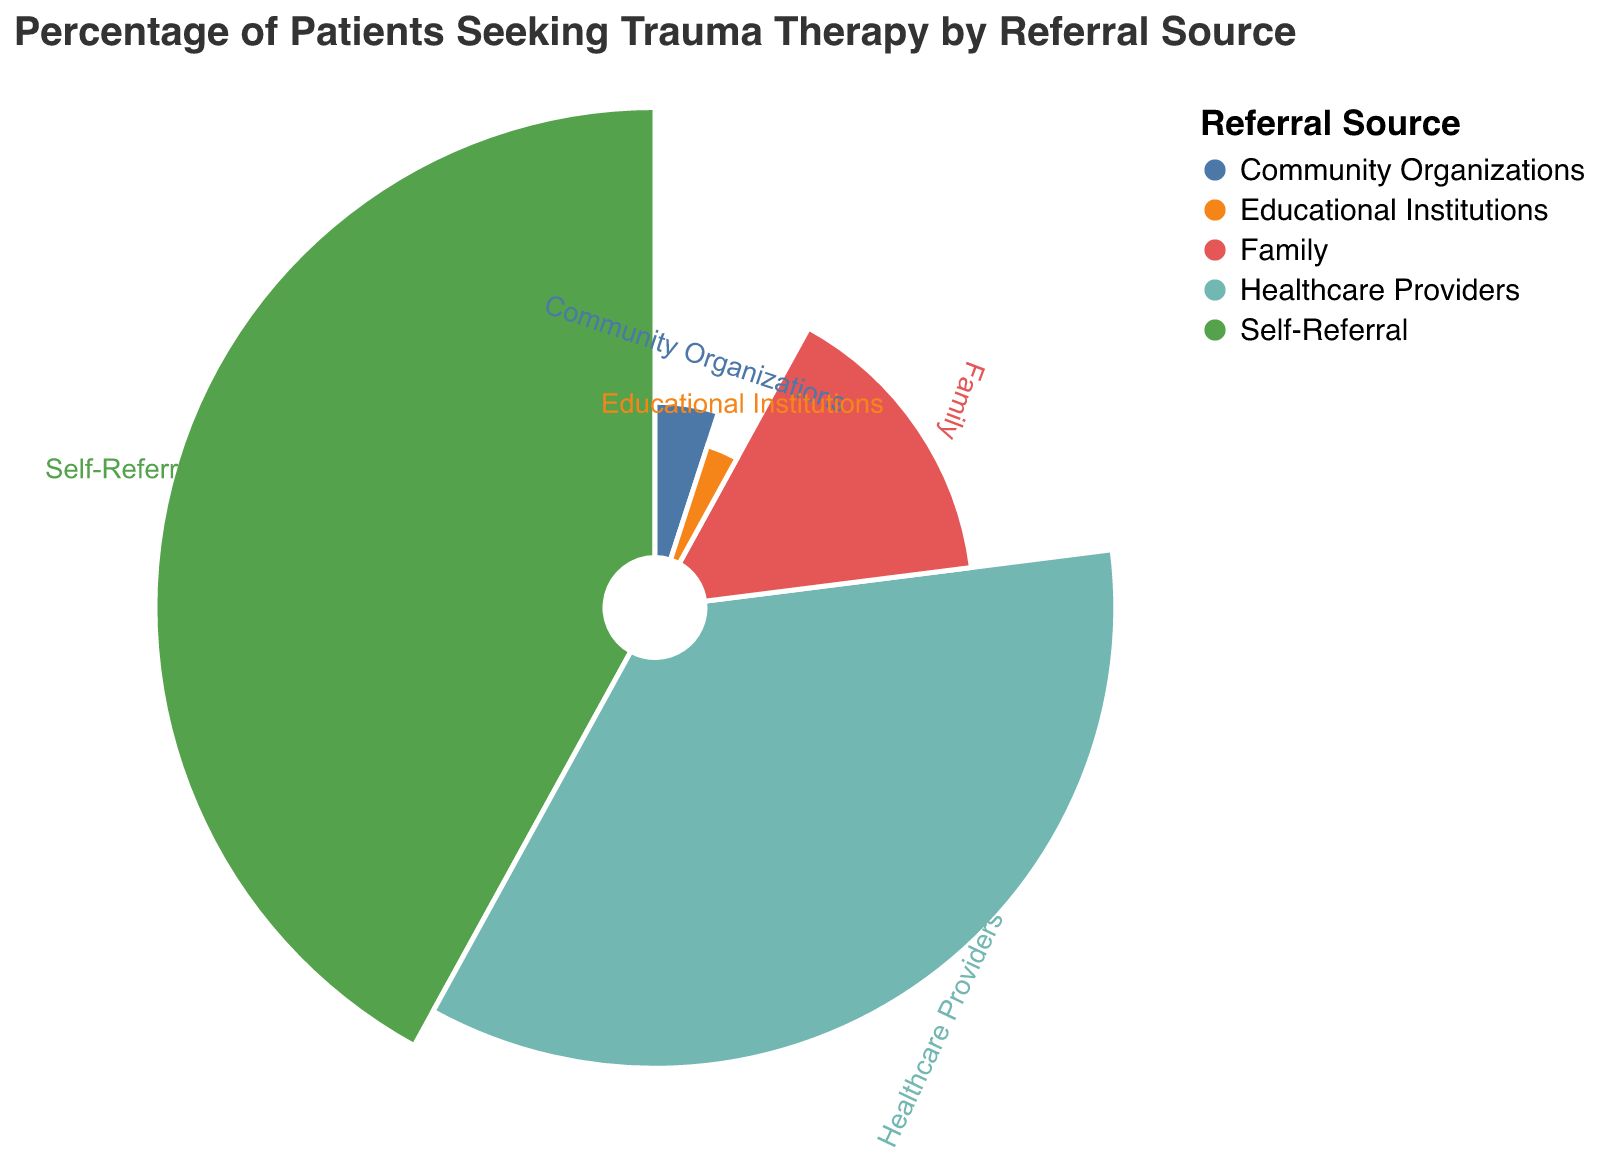What is the title of the figure? The title is located at the top center of the figure, displaying the purpose of the chart, which indicates what is being visualized.
Answer: Percentage of Patients Seeking Trauma Therapy by Referral Source Which referral source has the highest percentage of patients seeking trauma therapy? By looking at the lengths of the segments in the polar chart, the one with the largest segment corresponds to the highest percentage.
Answer: Self-Referral How many referral sources are displayed in the chart? Each differently colored segment in the polar chart represents a unique referral source.
Answer: Five What is the combined percentage of patients referred by family and healthcare providers? Identify the percentage for family (15%) and healthcare providers (35%) and sum the two values: 15 + 35.
Answer: 50% Which referral source contributes the least percentage of patients? This can be determined by comparing the sizes of the segments; the smallest segment represents the least percentage.
Answer: Educational Institutions Compare the percentage of patients referred by healthcare providers and those referred by family. Which is higher and by how much? Find the percentages for healthcare providers (35%) and family (15%) and then subtract the smaller percentage from the larger: 35 - 15.
Answer: Healthcare Providers by 20% What is the total percentage of patients referred by community organizations, educational institutions, and family? Add the percentages of community organizations (5%), educational institutions (3%), and family (15%): 5 + 3 + 15.
Answer: 23% By what percentage does self-referral exceed healthcare provider referrals? Find the difference between the percentages of self-referral (42%) and healthcare providers (35%): 42 - 35.
Answer: 7% Which two referral sources have a combined percentage closest to the percentage of self-referral? First, check the percentages individually and try combining them to find the sum closest to 42%. Family (15%) and Healthcare Providers (35%) total 50%, which is the closest compared to the other possible combinations.
Answer: Family and Healthcare Providers What is the distance from the center to the outer edge of the segment for community organizations, assuming the radius is scaled proportionally to the percentage? Since the radius is scaled proportionally to the percentage, and if we consider the radius of 100 units for the chart, the radius for community organizations would be proportional to 5% of the total: 5 units.
Answer: Proportionately 5 units (based on scale assumptions) 